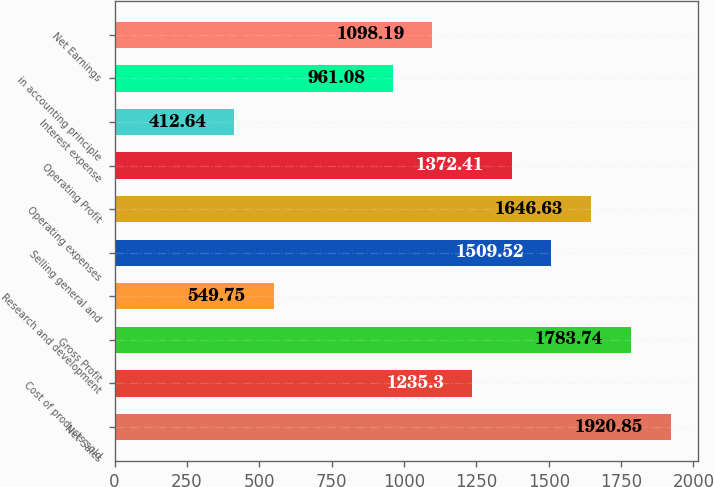Convert chart to OTSL. <chart><loc_0><loc_0><loc_500><loc_500><bar_chart><fcel>Net Sales<fcel>Cost of products sold<fcel>Gross Profit<fcel>Research and development<fcel>Selling general and<fcel>Operating expenses<fcel>Operating Profit<fcel>Interest expense<fcel>in accounting principle<fcel>Net Earnings<nl><fcel>1920.85<fcel>1235.3<fcel>1783.74<fcel>549.75<fcel>1509.52<fcel>1646.63<fcel>1372.41<fcel>412.64<fcel>961.08<fcel>1098.19<nl></chart> 